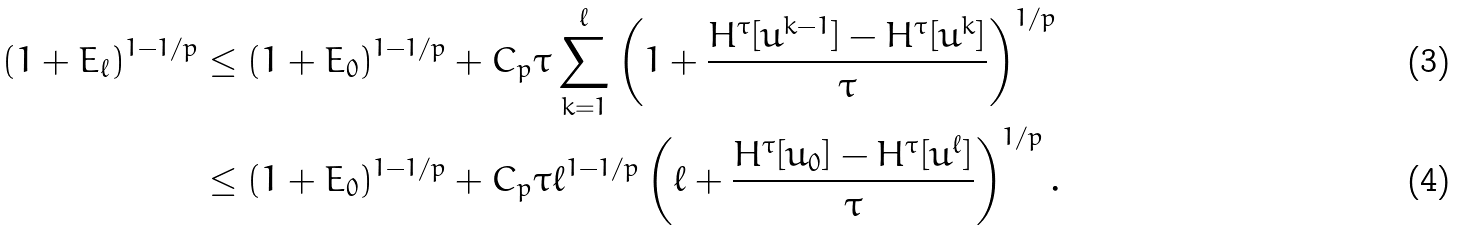Convert formula to latex. <formula><loc_0><loc_0><loc_500><loc_500>( 1 + E _ { \ell } ) ^ { 1 - 1 / p } & \leq ( 1 + E _ { 0 } ) ^ { 1 - 1 / p } + C _ { p } \tau \sum _ { k = 1 } ^ { \ell } \left ( 1 + \frac { H ^ { \tau } [ u ^ { k - 1 } ] - H ^ { \tau } [ u ^ { k } ] } { \tau } \right ) ^ { 1 / p } \\ & \leq ( 1 + E _ { 0 } ) ^ { 1 - 1 / p } + C _ { p } \tau \ell ^ { 1 - 1 / p } \left ( \ell + \frac { H ^ { \tau } [ u _ { 0 } ] - H ^ { \tau } [ u ^ { \ell } ] } { \tau } \right ) ^ { 1 / p } .</formula> 